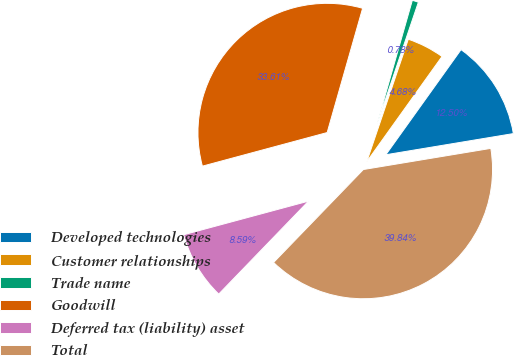Convert chart to OTSL. <chart><loc_0><loc_0><loc_500><loc_500><pie_chart><fcel>Developed technologies<fcel>Customer relationships<fcel>Trade name<fcel>Goodwill<fcel>Deferred tax (liability) asset<fcel>Total<nl><fcel>12.5%<fcel>4.68%<fcel>0.78%<fcel>33.61%<fcel>8.59%<fcel>39.84%<nl></chart> 